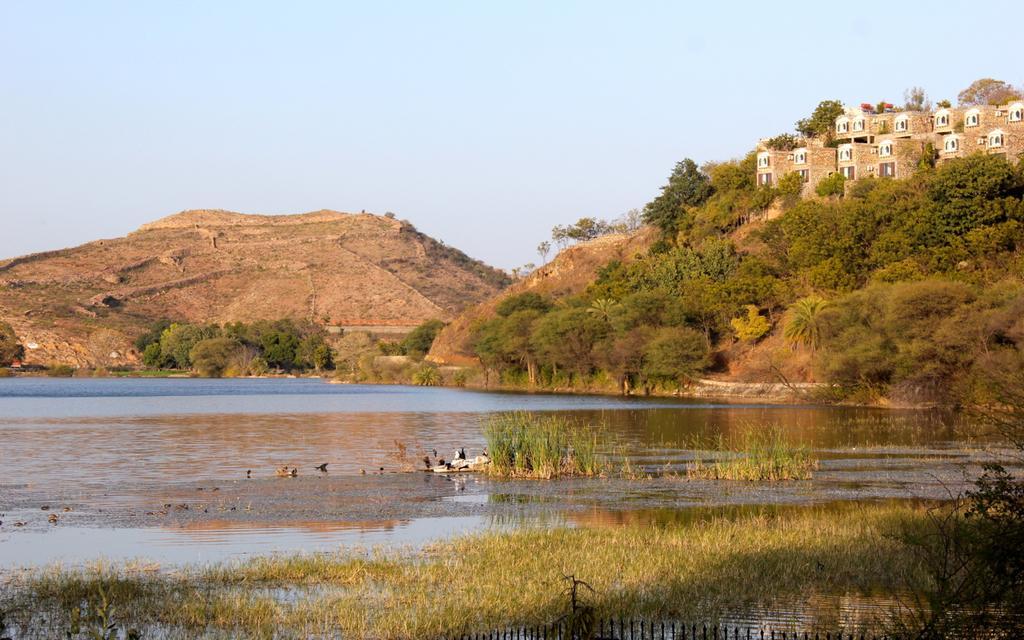Can you describe this image briefly? In the foreground of the picture there are birds, plants and water. In the center of the picture there are hills, buildings and trees. Sky is clear and it is sunny. 